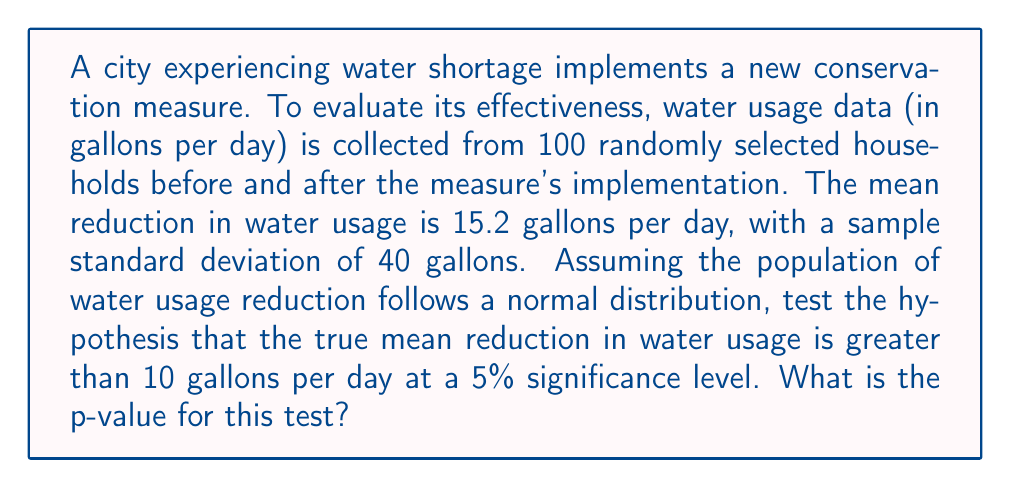What is the answer to this math problem? To test this hypothesis, we'll use a one-tailed t-test. Let's follow these steps:

1) Define the null and alternative hypotheses:
   $H_0: \mu \leq 10$ (null hypothesis)
   $H_a: \mu > 10$ (alternative hypothesis)
   where $\mu$ is the true mean reduction in water usage.

2) Calculate the t-statistic:
   $$t = \frac{\bar{x} - \mu_0}{s/\sqrt{n}}$$
   where $\bar{x}$ is the sample mean, $\mu_0$ is the hypothesized population mean, $s$ is the sample standard deviation, and $n$ is the sample size.

   $$t = \frac{15.2 - 10}{40/\sqrt{100}} = \frac{5.2}{4} = 1.3$$

3) Determine the degrees of freedom:
   $df = n - 1 = 100 - 1 = 99$

4) Find the p-value:
   The p-value is the probability of obtaining a t-statistic as extreme as or more extreme than the observed value, assuming the null hypothesis is true.

   Using a t-distribution table or calculator with 99 degrees of freedom and t = 1.3, we find:
   p-value $\approx 0.0985$

5) Compare the p-value to the significance level:
   Since 0.0985 > 0.05, we fail to reject the null hypothesis at the 5% significance level.
Answer: 0.0985 